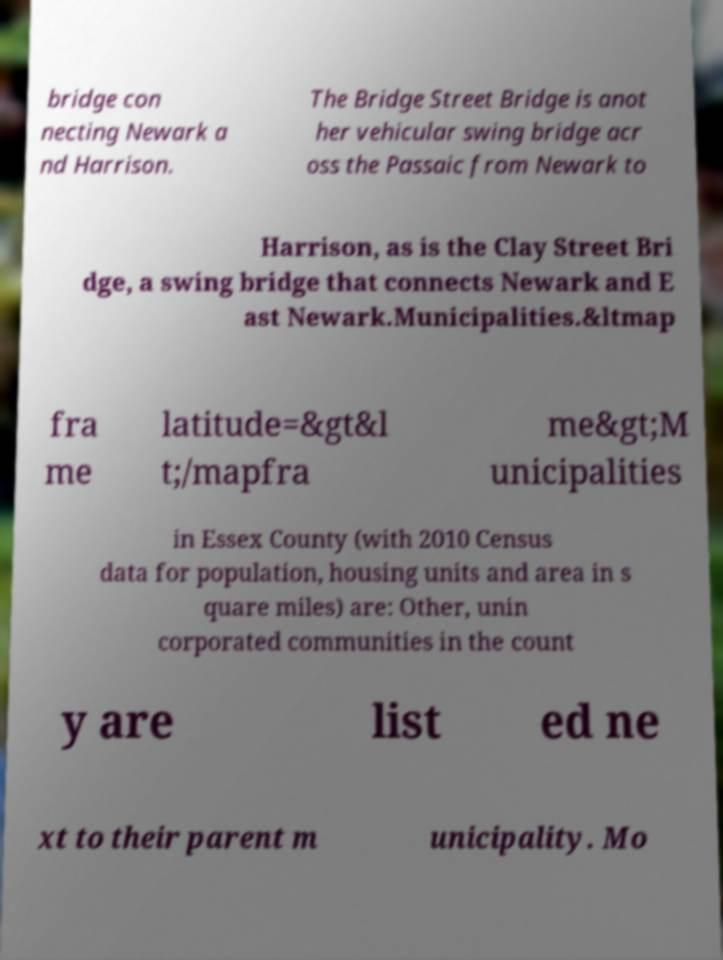Can you read and provide the text displayed in the image?This photo seems to have some interesting text. Can you extract and type it out for me? bridge con necting Newark a nd Harrison. The Bridge Street Bridge is anot her vehicular swing bridge acr oss the Passaic from Newark to Harrison, as is the Clay Street Bri dge, a swing bridge that connects Newark and E ast Newark.Municipalities.&ltmap fra me latitude=&gt&l t;/mapfra me&gt;M unicipalities in Essex County (with 2010 Census data for population, housing units and area in s quare miles) are: Other, unin corporated communities in the count y are list ed ne xt to their parent m unicipality. Mo 